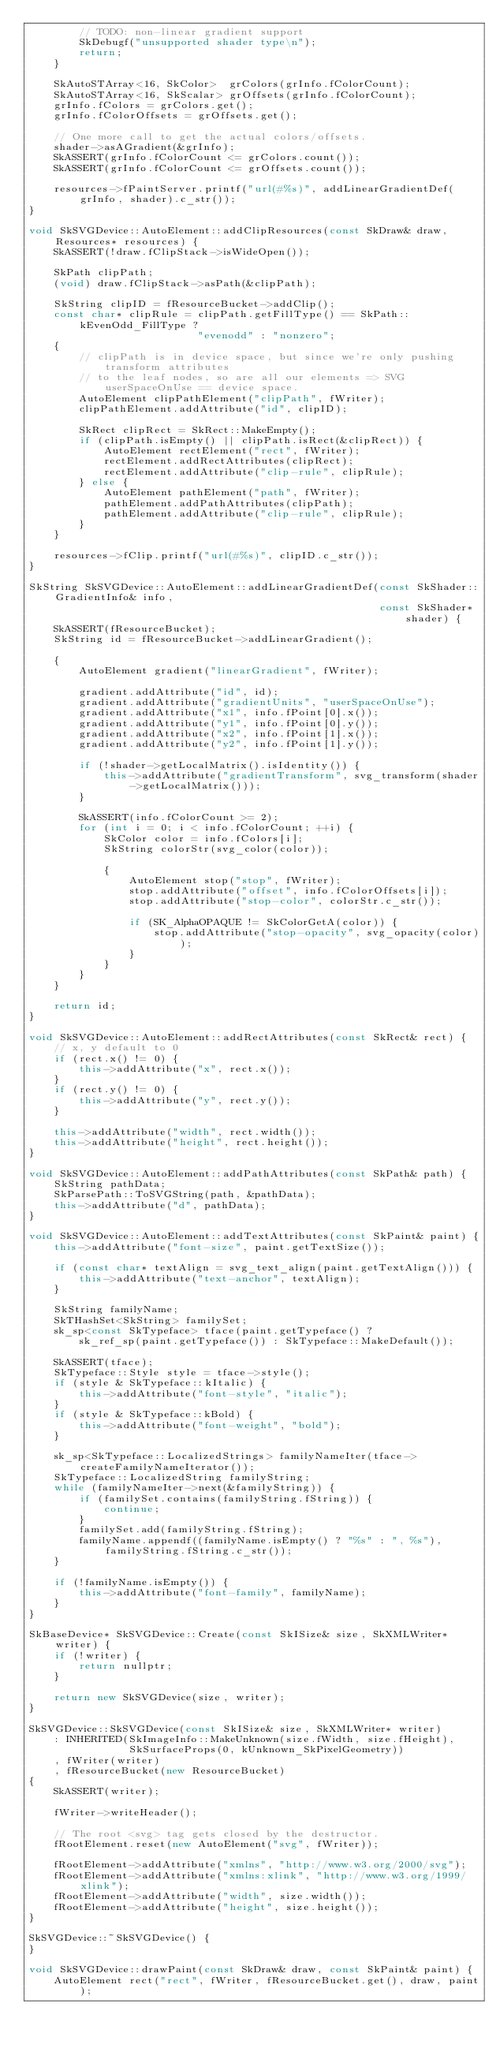<code> <loc_0><loc_0><loc_500><loc_500><_C++_>        // TODO: non-linear gradient support
        SkDebugf("unsupported shader type\n");
        return;
    }

    SkAutoSTArray<16, SkColor>  grColors(grInfo.fColorCount);
    SkAutoSTArray<16, SkScalar> grOffsets(grInfo.fColorCount);
    grInfo.fColors = grColors.get();
    grInfo.fColorOffsets = grOffsets.get();

    // One more call to get the actual colors/offsets.
    shader->asAGradient(&grInfo);
    SkASSERT(grInfo.fColorCount <= grColors.count());
    SkASSERT(grInfo.fColorCount <= grOffsets.count());

    resources->fPaintServer.printf("url(#%s)", addLinearGradientDef(grInfo, shader).c_str());
}

void SkSVGDevice::AutoElement::addClipResources(const SkDraw& draw, Resources* resources) {
    SkASSERT(!draw.fClipStack->isWideOpen());

    SkPath clipPath;
    (void) draw.fClipStack->asPath(&clipPath);

    SkString clipID = fResourceBucket->addClip();
    const char* clipRule = clipPath.getFillType() == SkPath::kEvenOdd_FillType ?
                           "evenodd" : "nonzero";
    {
        // clipPath is in device space, but since we're only pushing transform attributes
        // to the leaf nodes, so are all our elements => SVG userSpaceOnUse == device space.
        AutoElement clipPathElement("clipPath", fWriter);
        clipPathElement.addAttribute("id", clipID);

        SkRect clipRect = SkRect::MakeEmpty();
        if (clipPath.isEmpty() || clipPath.isRect(&clipRect)) {
            AutoElement rectElement("rect", fWriter);
            rectElement.addRectAttributes(clipRect);
            rectElement.addAttribute("clip-rule", clipRule);
        } else {
            AutoElement pathElement("path", fWriter);
            pathElement.addPathAttributes(clipPath);
            pathElement.addAttribute("clip-rule", clipRule);
        }
    }

    resources->fClip.printf("url(#%s)", clipID.c_str());
}

SkString SkSVGDevice::AutoElement::addLinearGradientDef(const SkShader::GradientInfo& info,
                                                        const SkShader* shader) {
    SkASSERT(fResourceBucket);
    SkString id = fResourceBucket->addLinearGradient();

    {
        AutoElement gradient("linearGradient", fWriter);

        gradient.addAttribute("id", id);
        gradient.addAttribute("gradientUnits", "userSpaceOnUse");
        gradient.addAttribute("x1", info.fPoint[0].x());
        gradient.addAttribute("y1", info.fPoint[0].y());
        gradient.addAttribute("x2", info.fPoint[1].x());
        gradient.addAttribute("y2", info.fPoint[1].y());

        if (!shader->getLocalMatrix().isIdentity()) {
            this->addAttribute("gradientTransform", svg_transform(shader->getLocalMatrix()));
        }

        SkASSERT(info.fColorCount >= 2);
        for (int i = 0; i < info.fColorCount; ++i) {
            SkColor color = info.fColors[i];
            SkString colorStr(svg_color(color));

            {
                AutoElement stop("stop", fWriter);
                stop.addAttribute("offset", info.fColorOffsets[i]);
                stop.addAttribute("stop-color", colorStr.c_str());

                if (SK_AlphaOPAQUE != SkColorGetA(color)) {
                    stop.addAttribute("stop-opacity", svg_opacity(color));
                }
            }
        }
    }

    return id;
}

void SkSVGDevice::AutoElement::addRectAttributes(const SkRect& rect) {
    // x, y default to 0
    if (rect.x() != 0) {
        this->addAttribute("x", rect.x());
    }
    if (rect.y() != 0) {
        this->addAttribute("y", rect.y());
    }

    this->addAttribute("width", rect.width());
    this->addAttribute("height", rect.height());
}

void SkSVGDevice::AutoElement::addPathAttributes(const SkPath& path) {
    SkString pathData;
    SkParsePath::ToSVGString(path, &pathData);
    this->addAttribute("d", pathData);
}

void SkSVGDevice::AutoElement::addTextAttributes(const SkPaint& paint) {
    this->addAttribute("font-size", paint.getTextSize());

    if (const char* textAlign = svg_text_align(paint.getTextAlign())) {
        this->addAttribute("text-anchor", textAlign);
    }

    SkString familyName;
    SkTHashSet<SkString> familySet;
    sk_sp<const SkTypeface> tface(paint.getTypeface() ?
        sk_ref_sp(paint.getTypeface()) : SkTypeface::MakeDefault());

    SkASSERT(tface);
    SkTypeface::Style style = tface->style();
    if (style & SkTypeface::kItalic) {
        this->addAttribute("font-style", "italic");
    }
    if (style & SkTypeface::kBold) {
        this->addAttribute("font-weight", "bold");
    }

    sk_sp<SkTypeface::LocalizedStrings> familyNameIter(tface->createFamilyNameIterator());
    SkTypeface::LocalizedString familyString;
    while (familyNameIter->next(&familyString)) {
        if (familySet.contains(familyString.fString)) {
            continue;
        }
        familySet.add(familyString.fString);
        familyName.appendf((familyName.isEmpty() ? "%s" : ", %s"), familyString.fString.c_str());
    }

    if (!familyName.isEmpty()) {
        this->addAttribute("font-family", familyName);
    }
}

SkBaseDevice* SkSVGDevice::Create(const SkISize& size, SkXMLWriter* writer) {
    if (!writer) {
        return nullptr;
    }

    return new SkSVGDevice(size, writer);
}

SkSVGDevice::SkSVGDevice(const SkISize& size, SkXMLWriter* writer)
    : INHERITED(SkImageInfo::MakeUnknown(size.fWidth, size.fHeight),
                SkSurfaceProps(0, kUnknown_SkPixelGeometry))
    , fWriter(writer)
    , fResourceBucket(new ResourceBucket)
{
    SkASSERT(writer);

    fWriter->writeHeader();

    // The root <svg> tag gets closed by the destructor.
    fRootElement.reset(new AutoElement("svg", fWriter));

    fRootElement->addAttribute("xmlns", "http://www.w3.org/2000/svg");
    fRootElement->addAttribute("xmlns:xlink", "http://www.w3.org/1999/xlink");
    fRootElement->addAttribute("width", size.width());
    fRootElement->addAttribute("height", size.height());
}

SkSVGDevice::~SkSVGDevice() {
}

void SkSVGDevice::drawPaint(const SkDraw& draw, const SkPaint& paint) {
    AutoElement rect("rect", fWriter, fResourceBucket.get(), draw, paint);</code> 